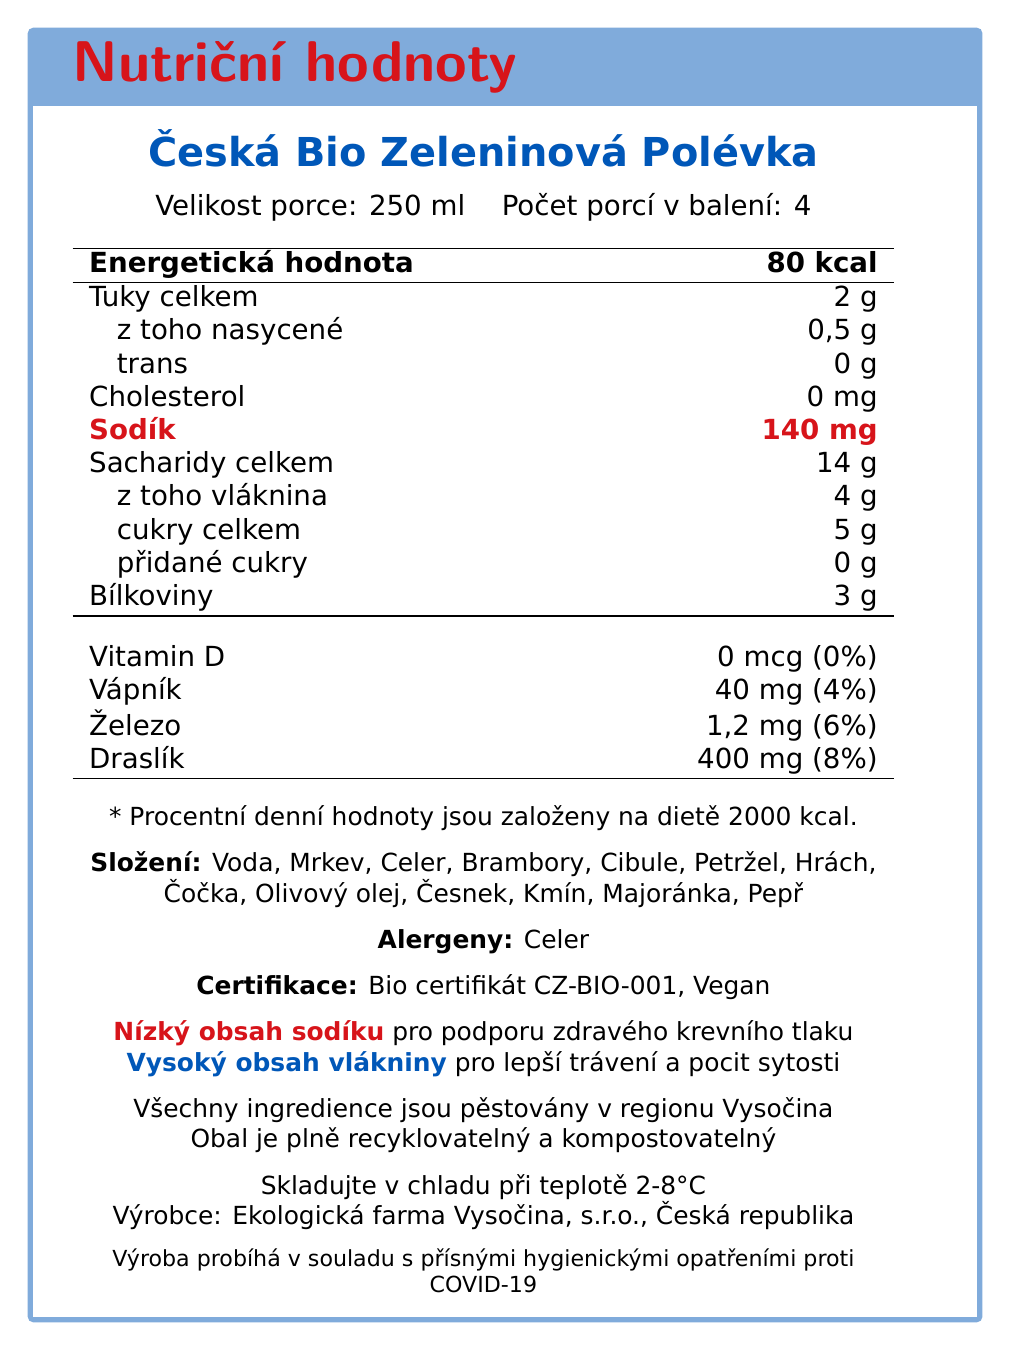what is the serving size for Česká Bio Zeleninová Polévka? The serving size is mentioned at the beginning of the document under the product name.
Answer: 250 ml how many servings are there per container? The number of servings is listed as "Počet porcí v balení: 4".
Answer: 4 how much sodium is in one serving of the soup? The amount of sodium per serving is listed in the nutrition facts table.
Answer: 140 mg what is the total dietary fiber content per serving? The dietary fiber per serving is 4 grams, as shown under the total carbohydrate section.
Answer: 4g which ingredient in the soup is an allergen? The allergen information states that "Celer" (celery) is an allergen.
Answer: Celer what certifications does the soup have? The document mentions these certifications under the "Certifikace" section.
Answer: Bio certifikát CZ-BIO-001, Vegan what is the producer's name? The producer's name is listed at the bottom of the document.
Answer: Ekologická farma Vysočina, s.r.o. where are all the ingredients sourced from? The additional information section states that all ingredients are grown in the Vysočina region.
Answer: Vysočina region what is the primary benefit of low sodium content? A. Improved digestion B. Healthy blood pressure C. Increased appetite The additional information section mentions that low sodium supports healthy blood pressure.
Answer: B which of the following is NOT an ingredient in the soup? 1. Olivový olej 2. Brambory 3. Hovězí maso 4. Čočka Hovězí maso (beef meat) is not listed as an ingredient.
Answer: 3 is there any added sugar in the soup? The nutrition facts state "přidané cukry" (added sugars) as 0 grams.
Answer: No is the packaging recyclable and compostable? The document states that the packaging is fully recyclable and compostable.
Answer: Yes Summarize the main nutritional and certification highlights of the Česká Bio Zeleninová Polévka. The document covers the key nutritional aspects, including low sodium and high fiber content, and highlights certifications and sustainability efforts.
Answer: The Česká Bio Zeleninová Polévka is an organic vegetable soup with a serving size of 250 ml. It contains 80 calories per serving, is low in sodium (140 mg), and high in dietary fiber (4g). The soup is certified with Bio certifikát CZ-BIO-001 and is vegan. It is locally sourced from the Vysočina region and its packaging is sustainable. what are the exact hygienic measures against COVID-19 implemented by the producer? The document states that production adheres to strict COVID-19 hygiene measures but does not specify the exact measures.
Answer: Not enough information 